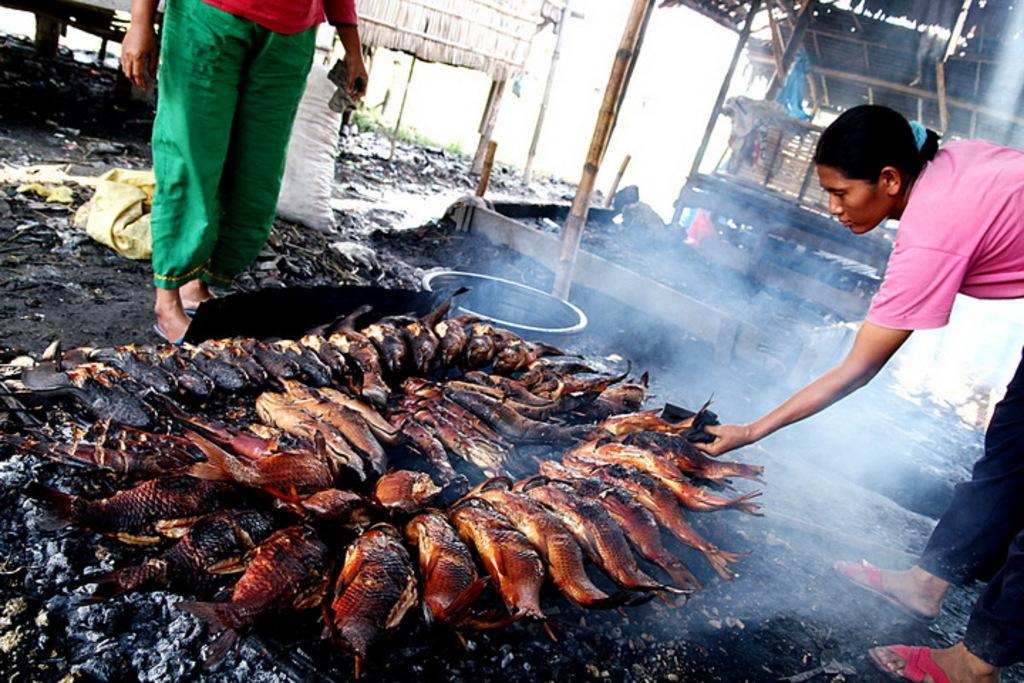What are the women in the image doing? The women in the image are cooking. What type of food are they cooking? They are cooking fish. What is being used to cook the food? Coal is being used for cooking. Can you describe any other objects present in the image? Wooden sticks, a shed, gunny bags, and the ground are visible in the image. What part of the natural environment can be seen in the image? The sky is visible in the image. What type of stove is being used for cooking in the image? There is no stove present in the image; the women are cooking using coal directly. Can you see any soldiers engaged in a battle in the image? No, there are no soldiers or any indication of a battle in the image. 